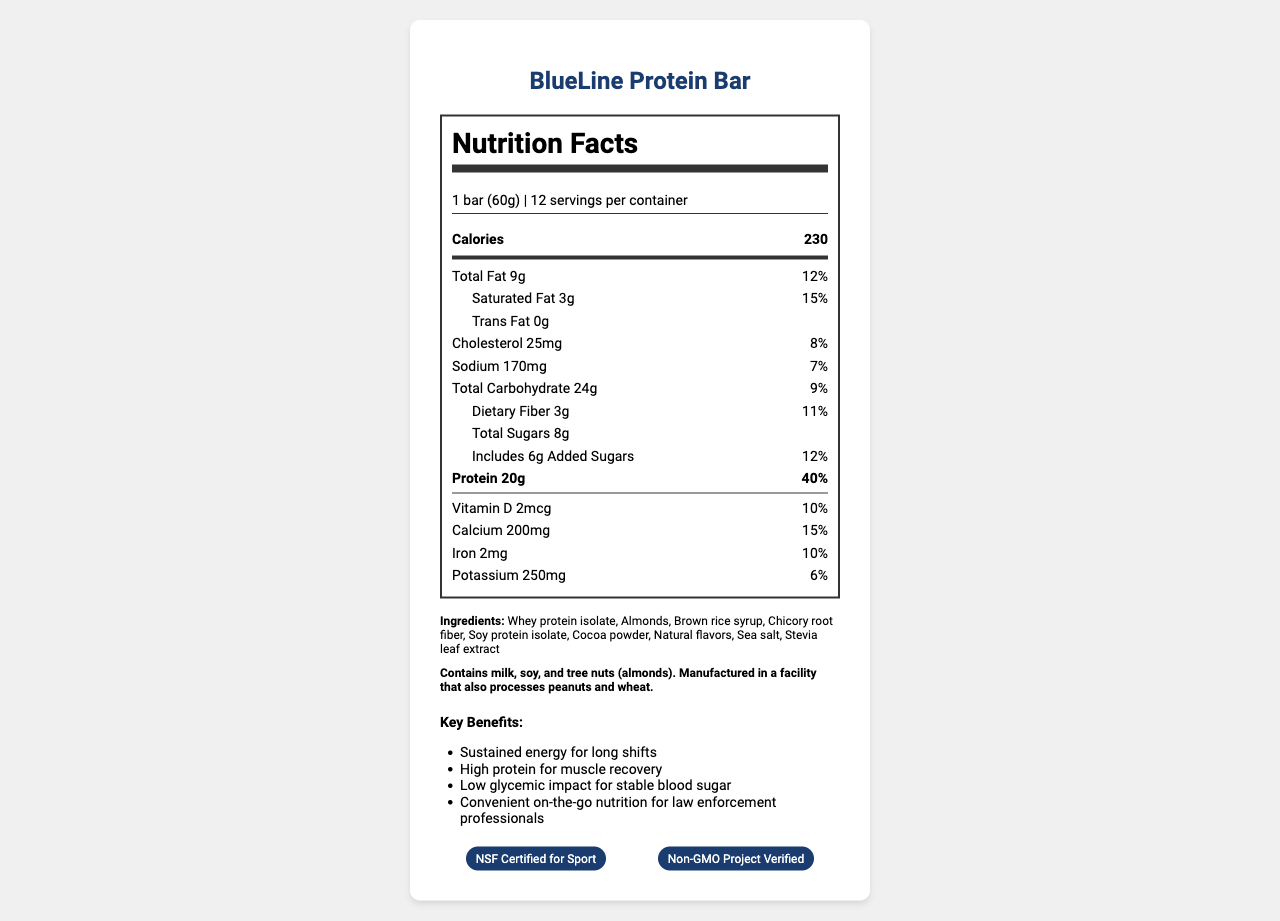what is the serving size of the BlueLine Protein Bar? The serving size is clearly stated as "1 bar (60g)" in the serving information section of the document.
Answer: 1 bar (60g) how many calories are there in one serving of the BlueLine Protein Bar? The document indicates that one serving contains 230 calories, located in the prominent "Calories" section.
Answer: 230 what are the key benefits of the BlueLine Protein Bar? The key benefits are listed under the "Key Benefits" section, including "Sustained energy for long shifts," "High protein for muscle recovery," "Low glycemic impact for stable blood sugar," and "Convenient on-the-go nutrition for law enforcement professionals."
Answer: Sustained energy, High protein, Low glycemic impact, Convenient on-the-go nutrition how much protein is in one bar, and what percentage of the daily value does it represent? The protein content is given as 20g, and it represents 40% of the daily value, located in the bold "Protein" section of the document.
Answer: 20g, 40% what are the ingredients of the BlueLine Protein Bar? The ingredients are listed after the main nutrient facts under the "Ingredients" section.
Answer: Whey protein isolate, Almonds, Brown rice syrup, Chicory root fiber, Soy protein isolate, Cocoa powder, Natural flavors, Sea salt, Stevia leaf extract Which statement is NOT listed as a key benefit of the BlueLine Protein Bar? A. High in Vitamin C B. Sustained energy for long shifts C. Low glycemic impact for stable blood sugar D. Convenient on-the-go nutrition The key benefits listed in the document do not mention "High in Vitamin C."
Answer: A What are the certifications received by the BlueLine Protein Bar? A. USDA Organic B. Gluten-Free Certified C. Non-GMO Project Verified D. NSF Certified for Sport The document lists "Non-GMO Project Verified" and "NSF Certified for Sport" as the certifications received by the product.
Answer: C and D Is the BlueLine Protein Bar suitable for someone with a peanut allergy? The allergen information states that it is manufactured in a facility that processes peanuts, which might pose a risk to someone with a peanut allergy.
Answer: No Did the document mention any information about Vitamin B12? The document does not contain any information about Vitamin B12. It mentions various other nutrients but does not list Vitamin B12.
Answer: No Summarize the entire document. The document comprehensively details the nutritional information of the BlueLine Protein Bar, including servings, calories, macronutrients, vitamins, and minerals. It lists ingredients, allergens, marketing claims, and certifications, summarizing all relevant nutritional and product information for law enforcement personnel.
Answer: The document provides detailed nutrition facts for the BlueLine Protein Bar, designed for law enforcement personnel. It includes serving size, calorie content, amounts of various fats, cholesterol, sodium, carbohydrates, sugars, protein, vitamins, and minerals. The ingredients, allergen information, key benefits, and certifications (NSF Certified for Sport and Non-GMO Project Verified) are also listed, making it a comprehensive guide to the product's nutritional profile and suitability. 